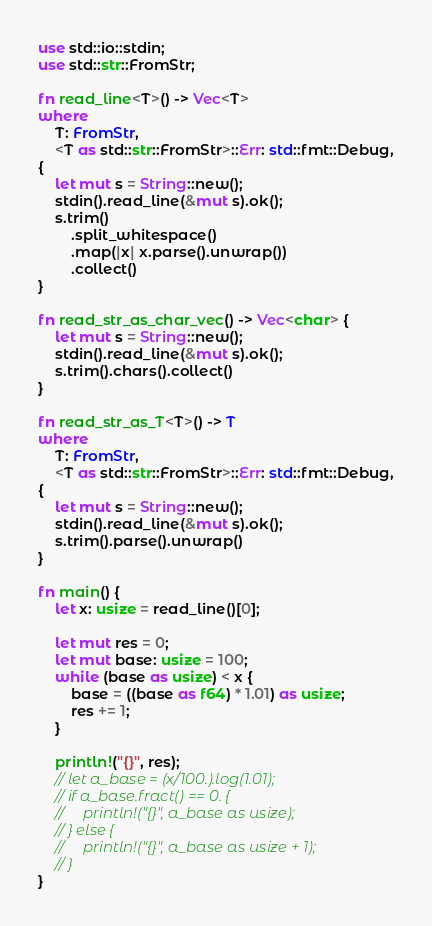<code> <loc_0><loc_0><loc_500><loc_500><_Rust_>use std::io::stdin;
use std::str::FromStr;

fn read_line<T>() -> Vec<T>
where
    T: FromStr,
    <T as std::str::FromStr>::Err: std::fmt::Debug,
{
    let mut s = String::new();
    stdin().read_line(&mut s).ok();
    s.trim()
        .split_whitespace()
        .map(|x| x.parse().unwrap())
        .collect()
}

fn read_str_as_char_vec() -> Vec<char> {
    let mut s = String::new();
    stdin().read_line(&mut s).ok();
    s.trim().chars().collect()
}

fn read_str_as_T<T>() -> T 
where
    T: FromStr,
    <T as std::str::FromStr>::Err: std::fmt::Debug,
{
    let mut s = String::new();
    stdin().read_line(&mut s).ok();
    s.trim().parse().unwrap()
}

fn main() {
    let x: usize = read_line()[0];

    let mut res = 0;
    let mut base: usize = 100;
    while (base as usize) < x {
        base = ((base as f64) * 1.01) as usize;
        res += 1;
    }

    println!("{}", res);
    // let a_base = (x/100.).log(1.01);
    // if a_base.fract() == 0. {
    //     println!("{}", a_base as usize);
    // } else {
    //     println!("{}", a_base as usize + 1);
    // }
}</code> 